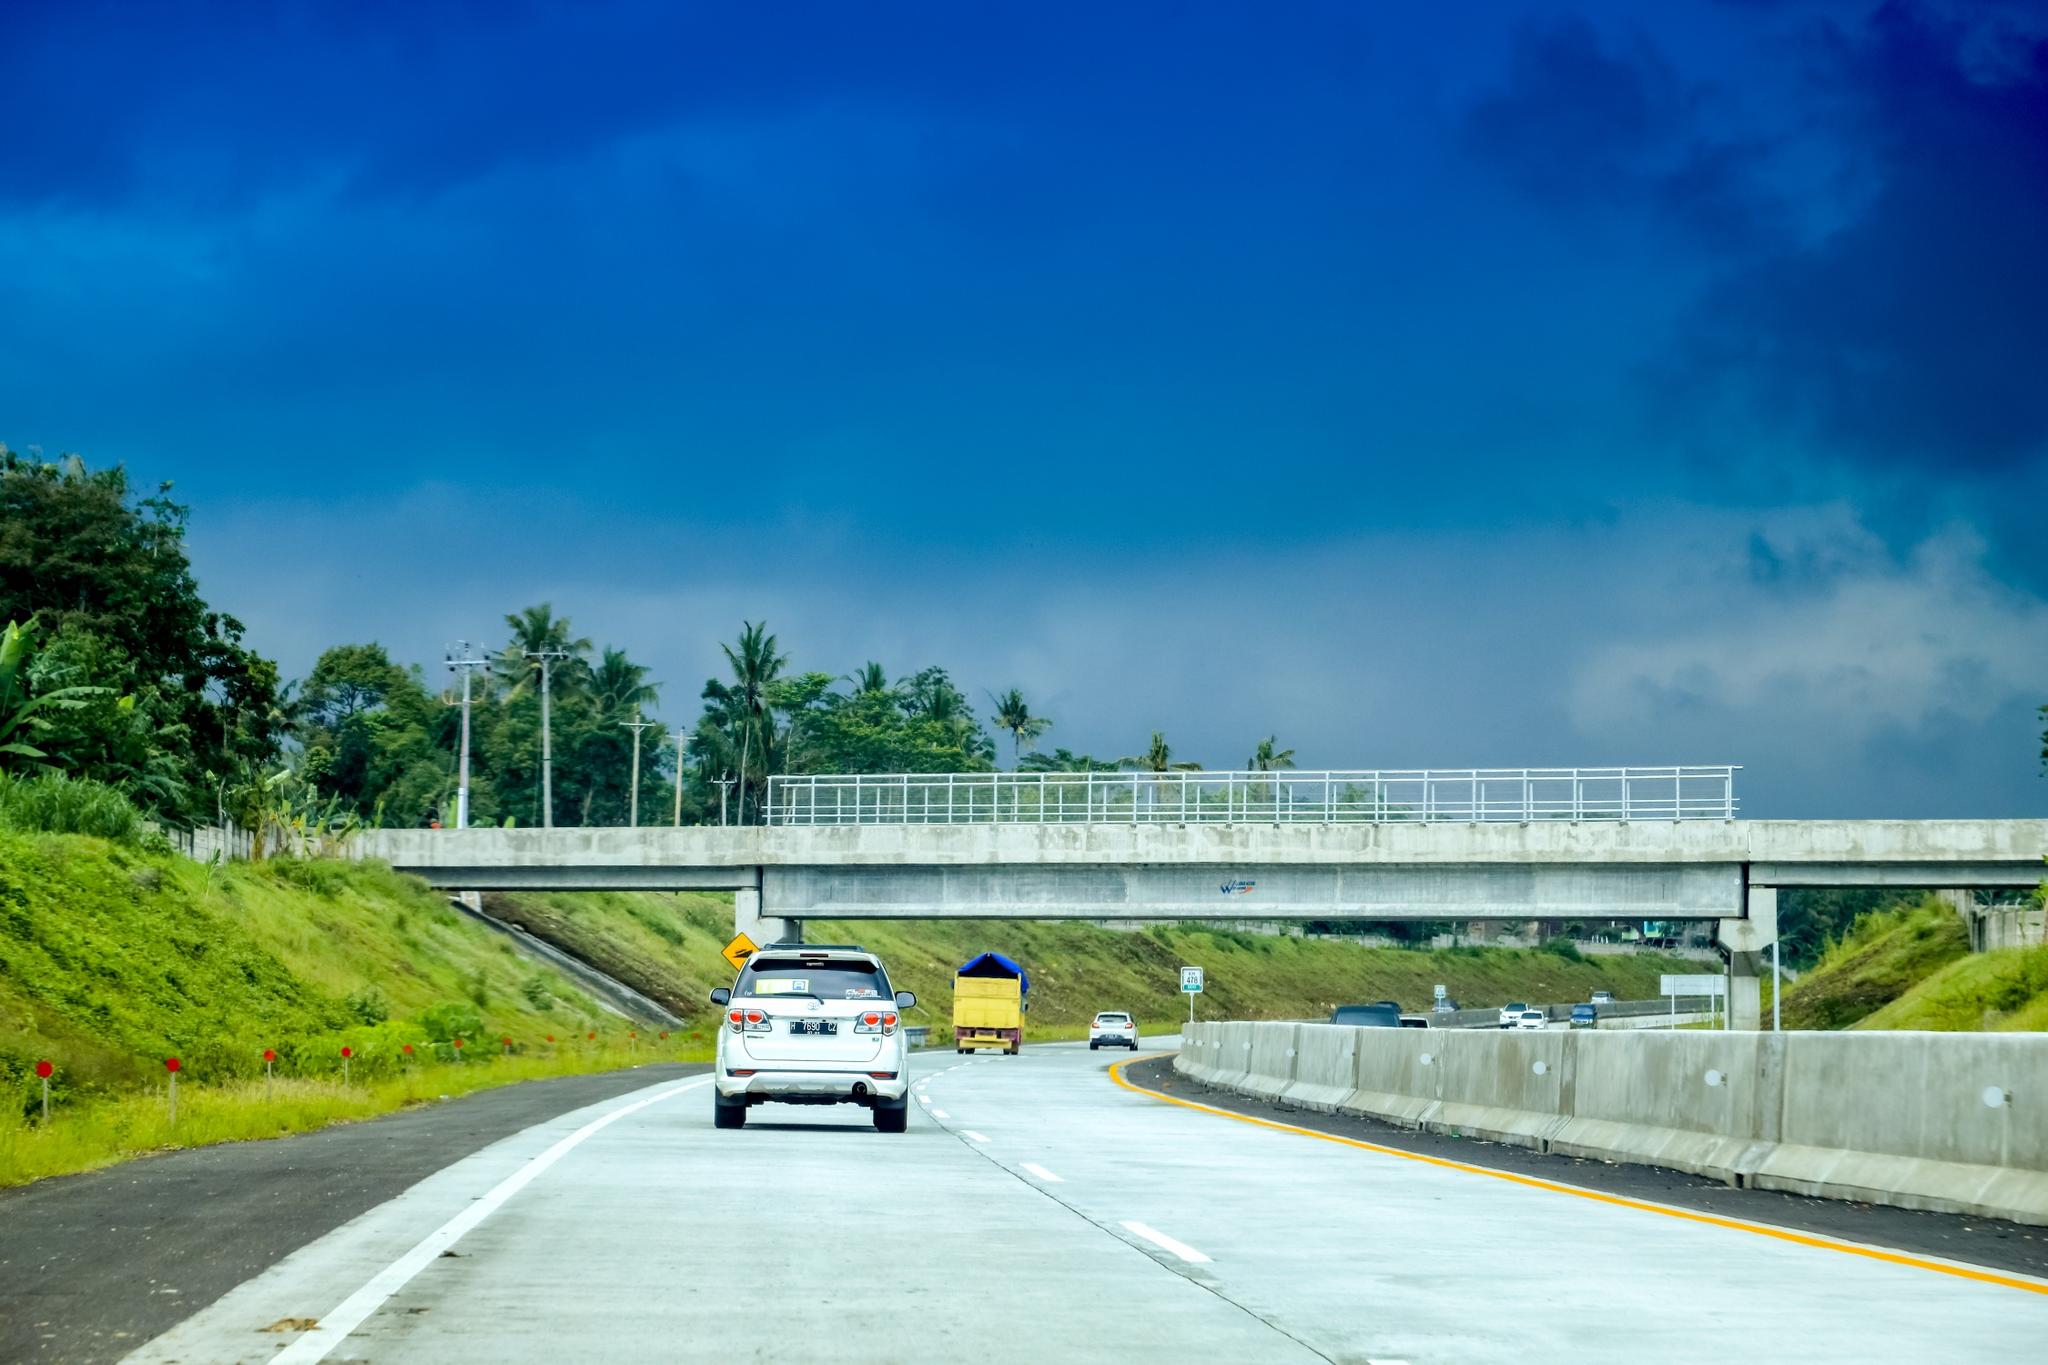Can you tell me a very short backstory for the white car? The white car belongs to a young couple on their honeymoon, exploring the beauty of the Philippines one serene drive at a time. 